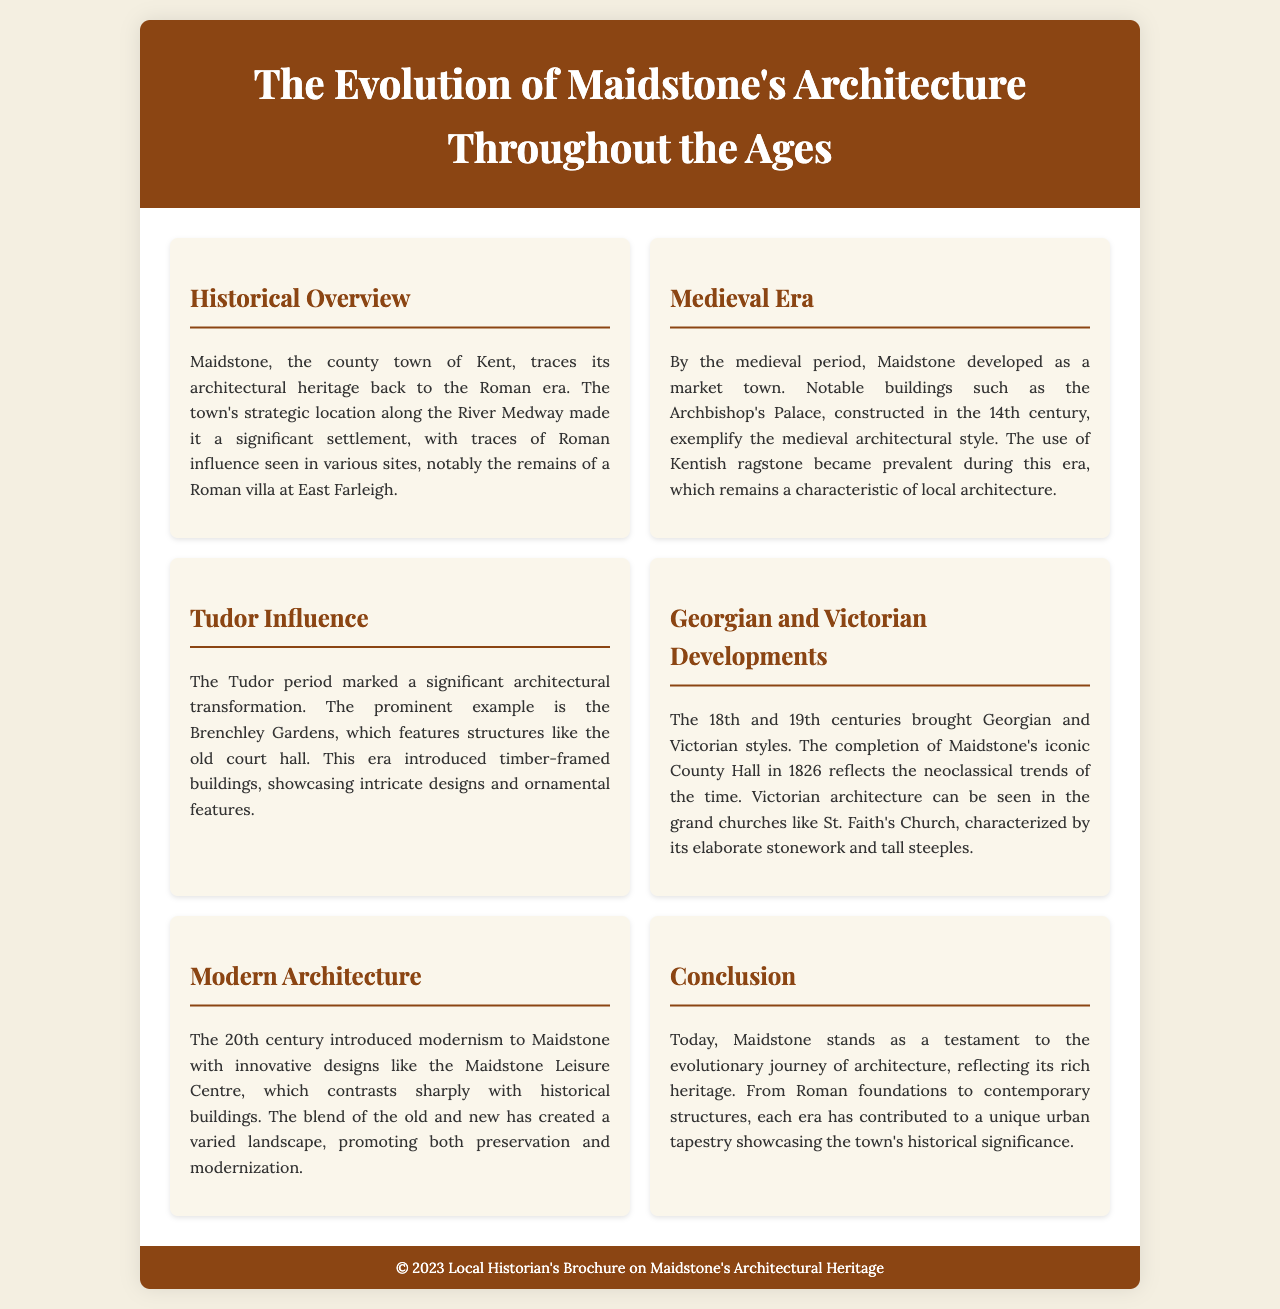What era is highlighted for its strategic location along the River Medway? The document states that Maidstone's architectural heritage dates back to the Roman era, which was significant due to its location along the River Medway.
Answer: Roman era What notable building was constructed in the 14th century? The brochure mentions the Archbishop's Palace as a notable building from the medieval period, highlighting its construction in the 14th century.
Answer: Archbishop's Palace Which architectural style is reflected in Maidstone's County Hall completed in 1826? The brochure describes Maidstone's County Hall as a reflection of neoclassical trends, which characterized the architectural style of the time.
Answer: Neoclassical What material became prevalent during the medieval period? The document specifies that Kentish ragstone became a prevalent building material during the medieval era in Maidstone.
Answer: Kentish ragstone Which garden features structures from the Tudor period? Brenchley Gardens is cited in the brochure as a prominent example of Tudor architectural influence showcasing intricate designs.
Answer: Brenchley Gardens What transition in architecture occurred in the 20th century? The document states that modernism was introduced to Maidstone during the 20th century, showcasing how the architectural landscape evolved.
Answer: Modernism What is the overall theme of the brochure? The entire document centers on the theme of Maidstone's architectural evolution throughout various historical periods and styles.
Answer: Architectural evolution What type of structure is St. Faith's Church known for? The brochure describes St. Faith's Church as a grand church characterized by its elaborate stonework and tall steeples during the Victorian era.
Answer: Elaborate stonework and tall steeples 